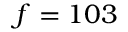<formula> <loc_0><loc_0><loc_500><loc_500>f = 1 0 3</formula> 